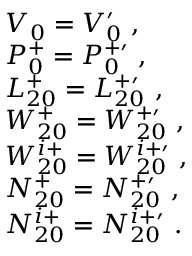Convert formula to latex. <formula><loc_0><loc_0><loc_500><loc_500>\begin{array} { r l } & { V _ { 0 } = V _ { 0 } ^ { \prime } , } \\ & { P _ { 0 } ^ { + } = P _ { 0 } ^ { + \prime } , } \\ & { L _ { 2 0 } ^ { + } = L _ { 2 0 } ^ { + \prime } , } \\ & { W _ { 2 0 } ^ { + } = W _ { 2 0 } ^ { + \prime } , } \\ & { W _ { 2 0 } ^ { i + } = W _ { 2 0 } ^ { i + \prime } , } \\ & { N _ { 2 0 } ^ { + } = N _ { 2 0 } ^ { + \prime } , } \\ & { N _ { 2 0 } ^ { i + } = N _ { 2 0 } ^ { i + \prime } . } \end{array}</formula> 